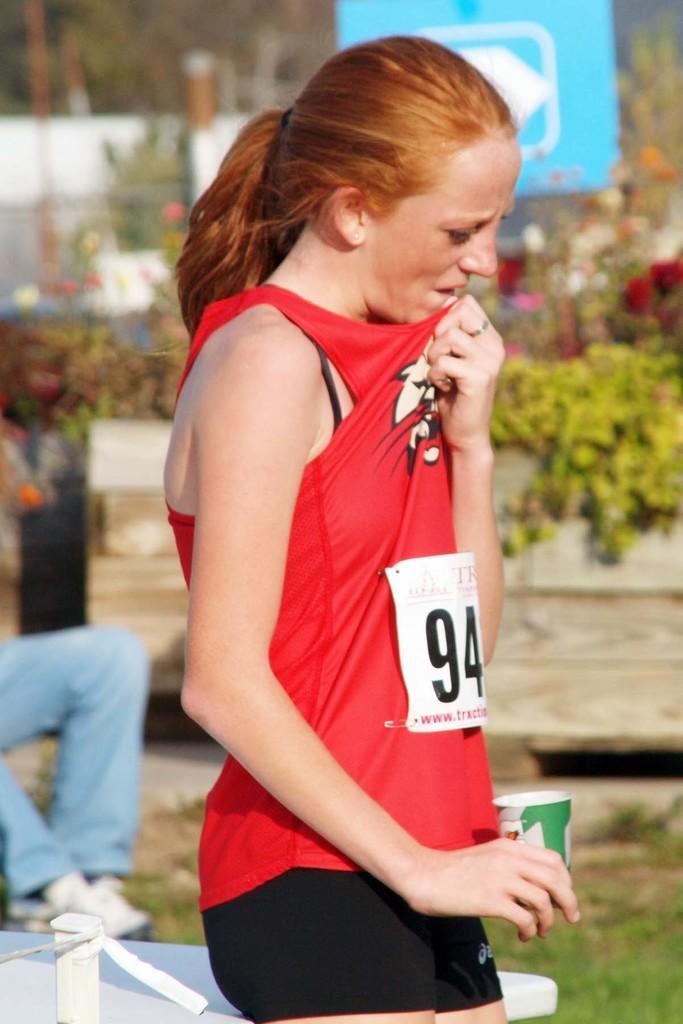Could you give a brief overview of what you see in this image? In this image we can see a woman standing and holding a disposal tumblr in her hands. In the background we can see plants and flowers. 